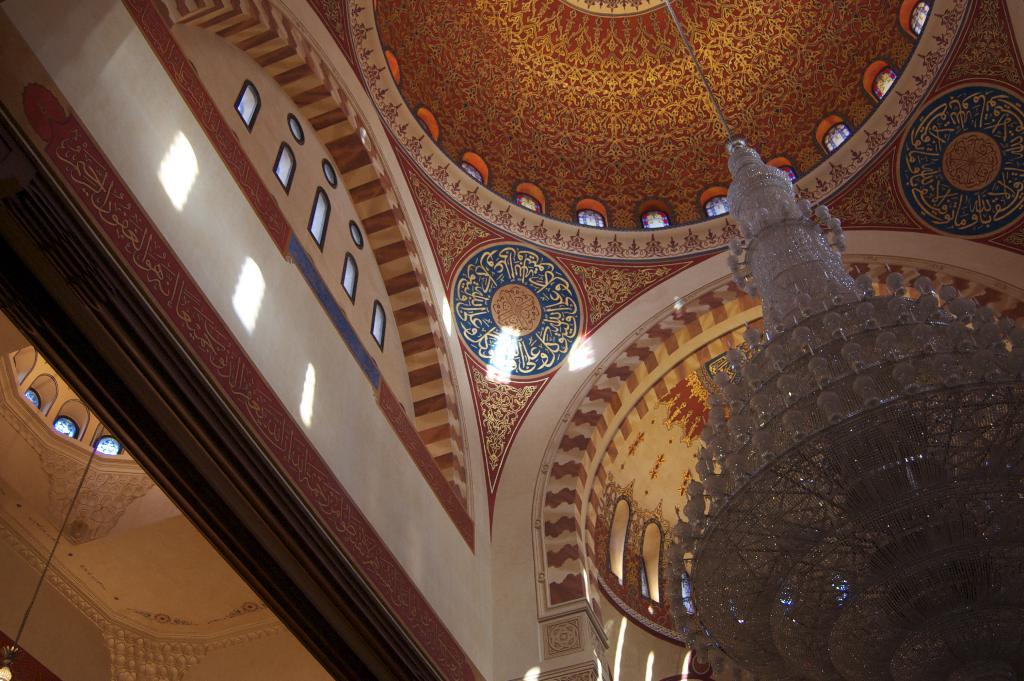What type of location is depicted in the image? The image is an inside view of a building. What can be seen illuminating the space in the image? There are lights visible in the image. What is above the space in the image? There is a ceiling in the image. What is visible at the very top of the image? The roof is visible at the top of the image. Can you tell me how many baseballs are on the ceiling in the image? There are no baseballs present in the image; it is an inside view of a building with lights, a ceiling, and a visible roof. 